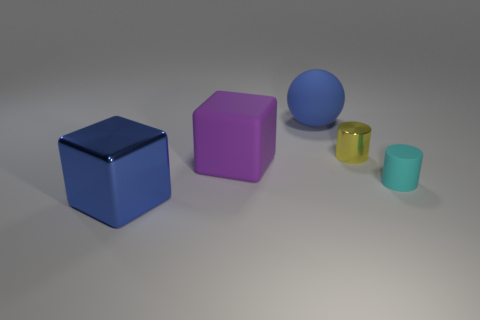Add 5 cyan metal cylinders. How many objects exist? 10 Subtract all cubes. How many objects are left? 3 Subtract 0 green cylinders. How many objects are left? 5 Subtract all blue cylinders. Subtract all small cylinders. How many objects are left? 3 Add 5 big blue metal blocks. How many big blue metal blocks are left? 6 Add 1 brown balls. How many brown balls exist? 1 